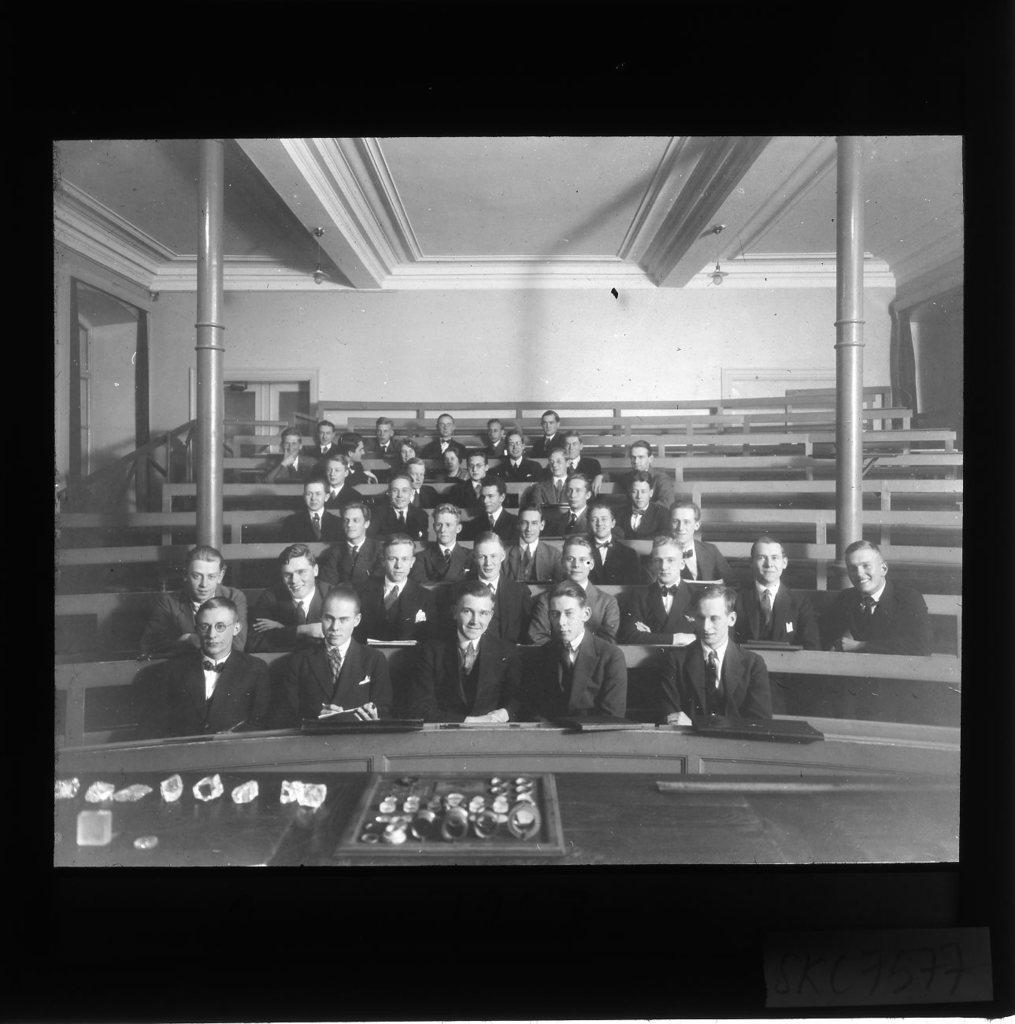Please provide a concise description of this image. This is a black and white picture. At the top we can see the ceiling and the lights. In the background we can see the wall and the door. We can see the poles. In this picture we can see the people in the same attire and they all are sitting on the benches. At the bottom portion of the picture we can see few objects. Borders of the image are in black color. In the bottom right corner of the image we can see there is something written. 